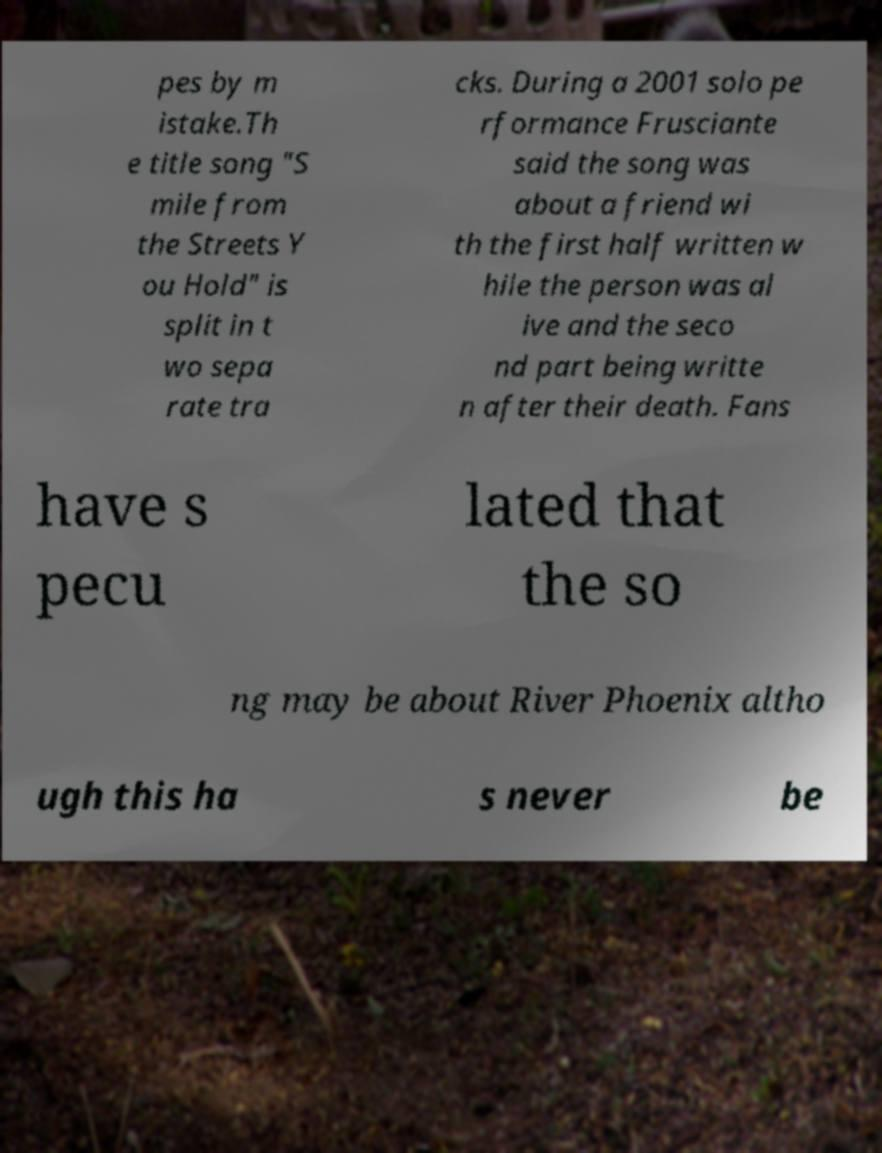Please identify and transcribe the text found in this image. pes by m istake.Th e title song "S mile from the Streets Y ou Hold" is split in t wo sepa rate tra cks. During a 2001 solo pe rformance Frusciante said the song was about a friend wi th the first half written w hile the person was al ive and the seco nd part being writte n after their death. Fans have s pecu lated that the so ng may be about River Phoenix altho ugh this ha s never be 